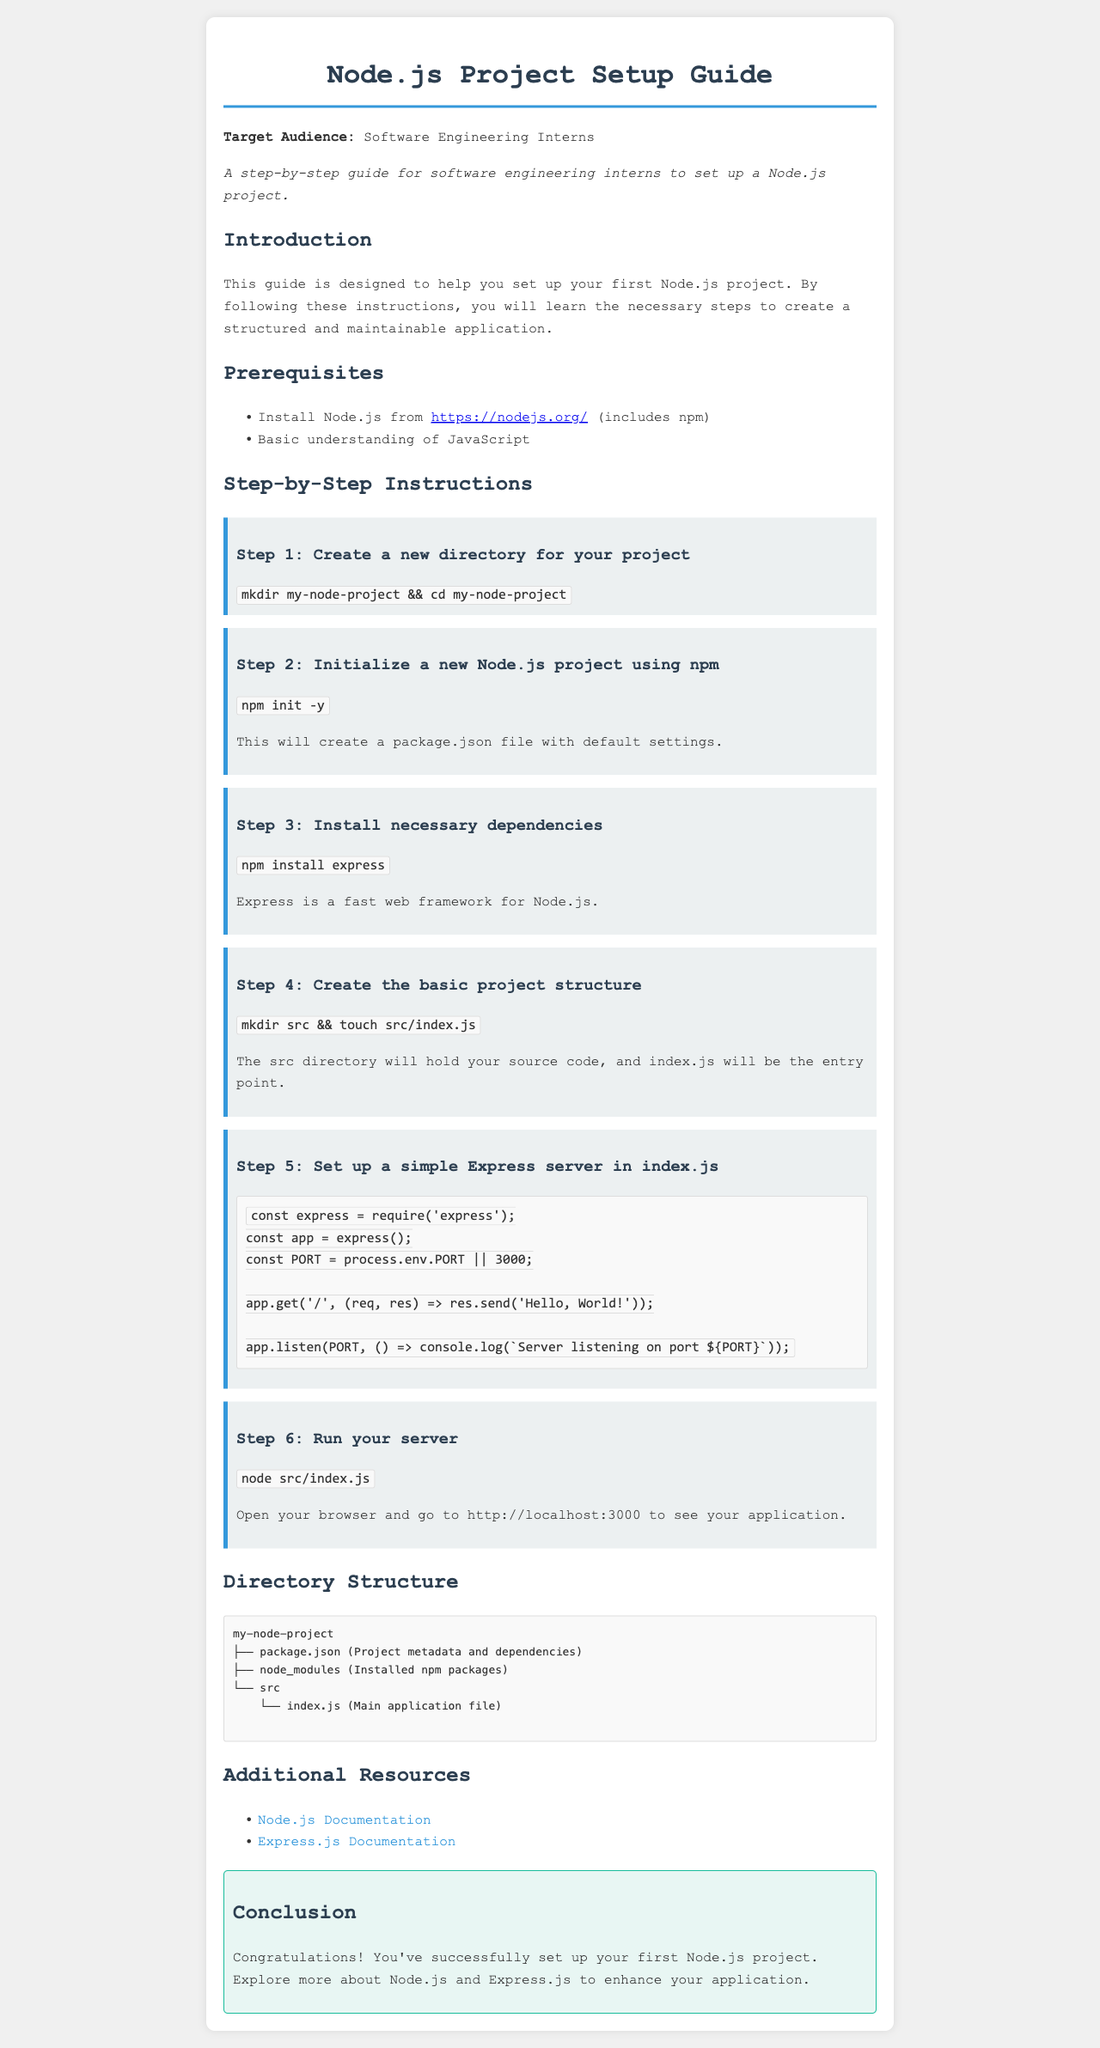What is the title of the document? The title is the main heading of the document, as it's specified in the <title> tag.
Answer: Node.js Project Setup Guide What is the first step in the instructions? The first step outlines the initial action to take when setting up the project.
Answer: Create a new directory for your project How many steps are there in the step-by-step instructions? The document provides a list of the steps in a sequential manner.
Answer: Six What does the package.json file contain? The package.json file is mentioned to hold specific types of information about the project.
Answer: Project metadata and dependencies Which framework is installed in step 3? The framework mentioned in step 3 is specifically outlined in the instructions.
Answer: Express What command is used to run the server? The document specifies the command to initiate the server in a clear manner.
Answer: node src/index.js What directory holds the main application file? The document indicates where the main application file is located within the project structure.
Answer: src What message does the server respond with at the root route? The response message from the server is explicitly stated in the instructions.
Answer: Hello, World! Which resource is recommended for more information about Node.js? The document lists additional resource links for further reading.
Answer: Node.js Documentation 